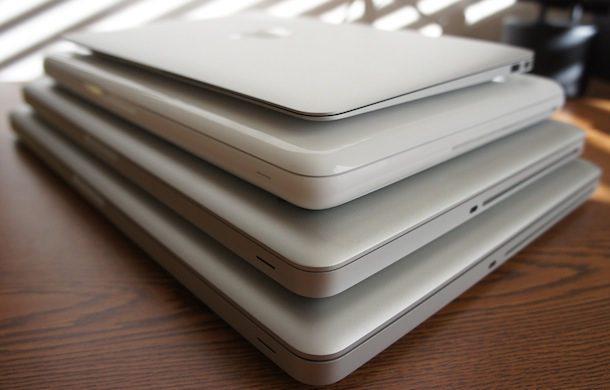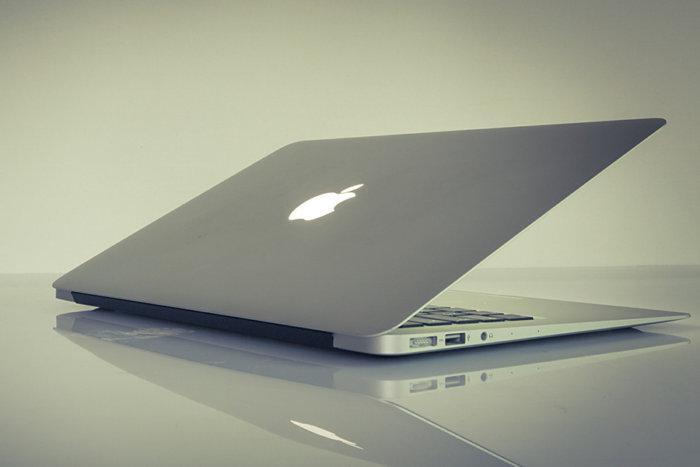The first image is the image on the left, the second image is the image on the right. Assess this claim about the two images: "The left image shows a neat stack of at least three white laptop-type devices.". Correct or not? Answer yes or no. Yes. The first image is the image on the left, the second image is the image on the right. Analyze the images presented: Is the assertion "In the image to the right, several electronic objects are stacked on top of each other." valid? Answer yes or no. No. 